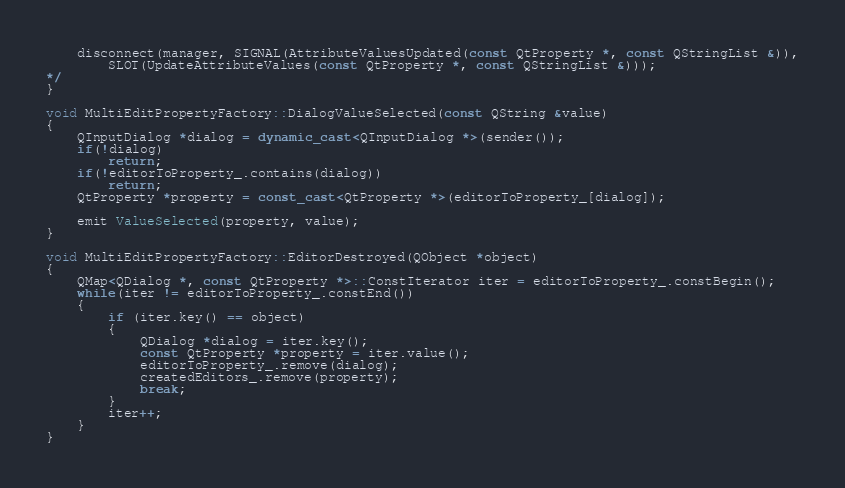<code> <loc_0><loc_0><loc_500><loc_500><_C++_>    disconnect(manager, SIGNAL(AttributeValuesUpdated(const QtProperty *, const QStringList &)),
        SLOT(UpdateAttributeValues(const QtProperty *, const QStringList &)));
*/
}

void MultiEditPropertyFactory::DialogValueSelected(const QString &value)
{
    QInputDialog *dialog = dynamic_cast<QInputDialog *>(sender());
    if(!dialog)
        return;
    if(!editorToProperty_.contains(dialog))
        return;
    QtProperty *property = const_cast<QtProperty *>(editorToProperty_[dialog]);

    emit ValueSelected(property, value);
}

void MultiEditPropertyFactory::EditorDestroyed(QObject *object)
{
    QMap<QDialog *, const QtProperty *>::ConstIterator iter = editorToProperty_.constBegin();
    while(iter != editorToProperty_.constEnd())
    {
        if (iter.key() == object)
        {
            QDialog *dialog = iter.key();
            const QtProperty *property = iter.value();
            editorToProperty_.remove(dialog);
            createdEditors_.remove(property);
            break;
        }
        iter++;
    }
}
</code> 